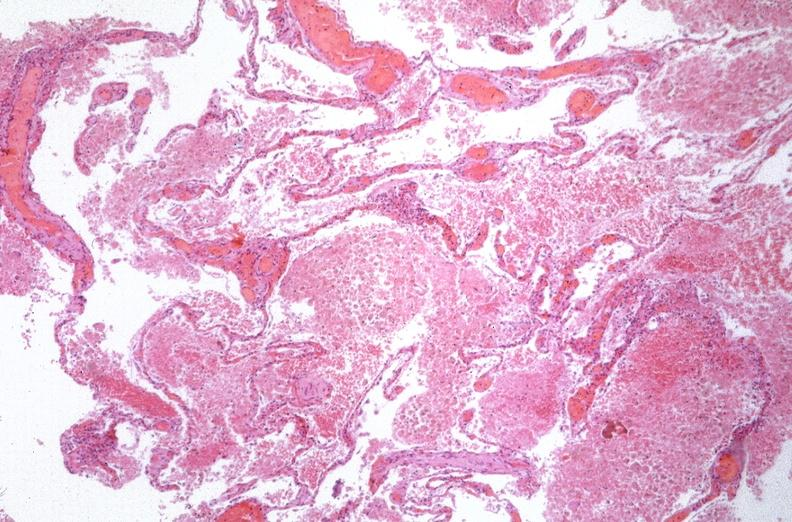what does this image show?
Answer the question using a single word or phrase. Lung 